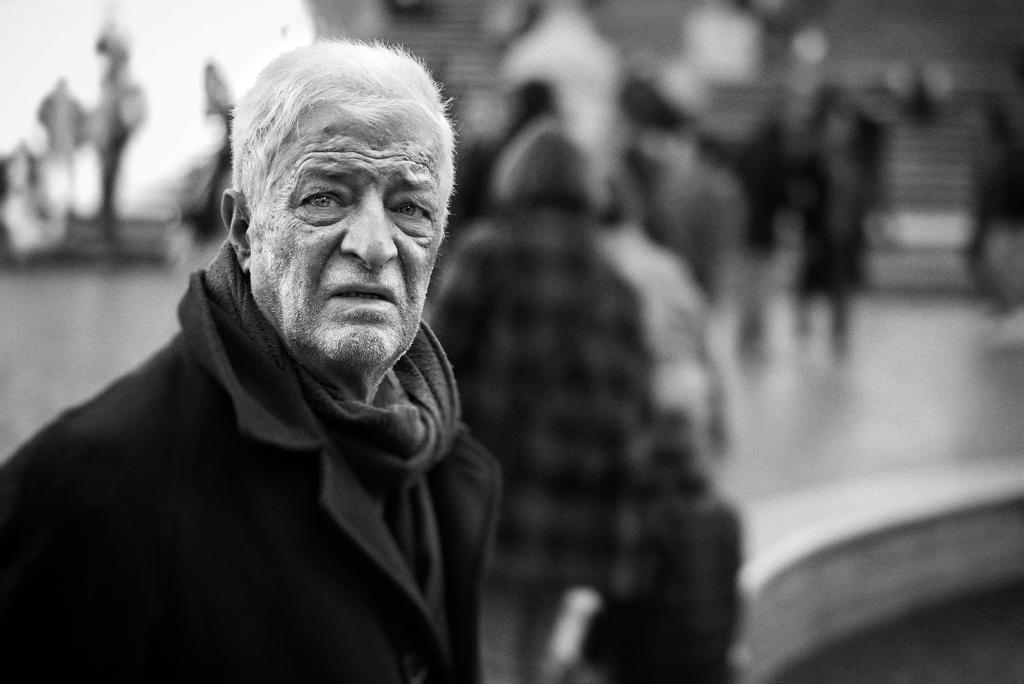What is the color scheme of the image? The image is black and white. Where is the man located in the image? The man is on the left side of the image. What is the man wearing in the image? The man is wearing a black dress in the image. What can be seen in the background of the image? There is a group of people in the background of the image. What type of polish is the man applying to the tray in the image? There is no tray or polish present in the image; the man is wearing a black dress and standing on the left side of the image. 